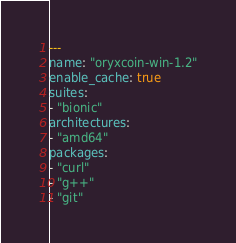Convert code to text. <code><loc_0><loc_0><loc_500><loc_500><_YAML_>---
name: "oryxcoin-win-1.2"
enable_cache: true
suites:
- "bionic"
architectures:
- "amd64"
packages:
- "curl"
- "g++"
- "git"</code> 